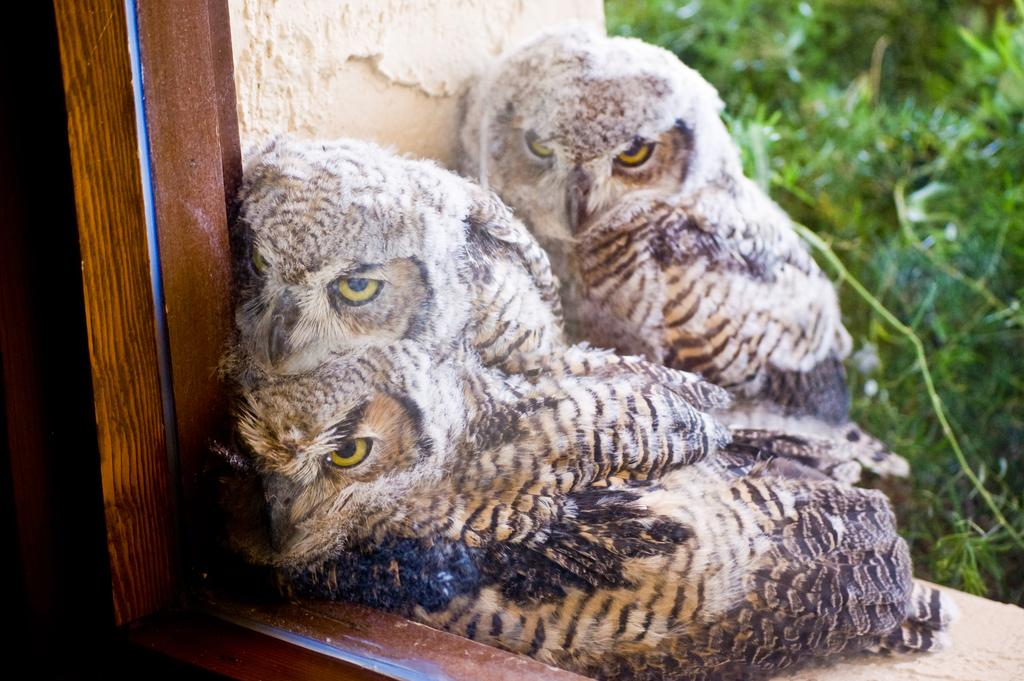How many owls are present in the image? There are three owls in the image. What else can be seen in the image besides the owls? There is a plant and a window in the image. Can you describe the window in the image? The window is made up of glass and wood. Is there any snow visible in the image? No, there is no snow present in the image. What type of bird can be seen flying through the window in the image? There are no birds flying through the window in the image; only the three owls are present. 